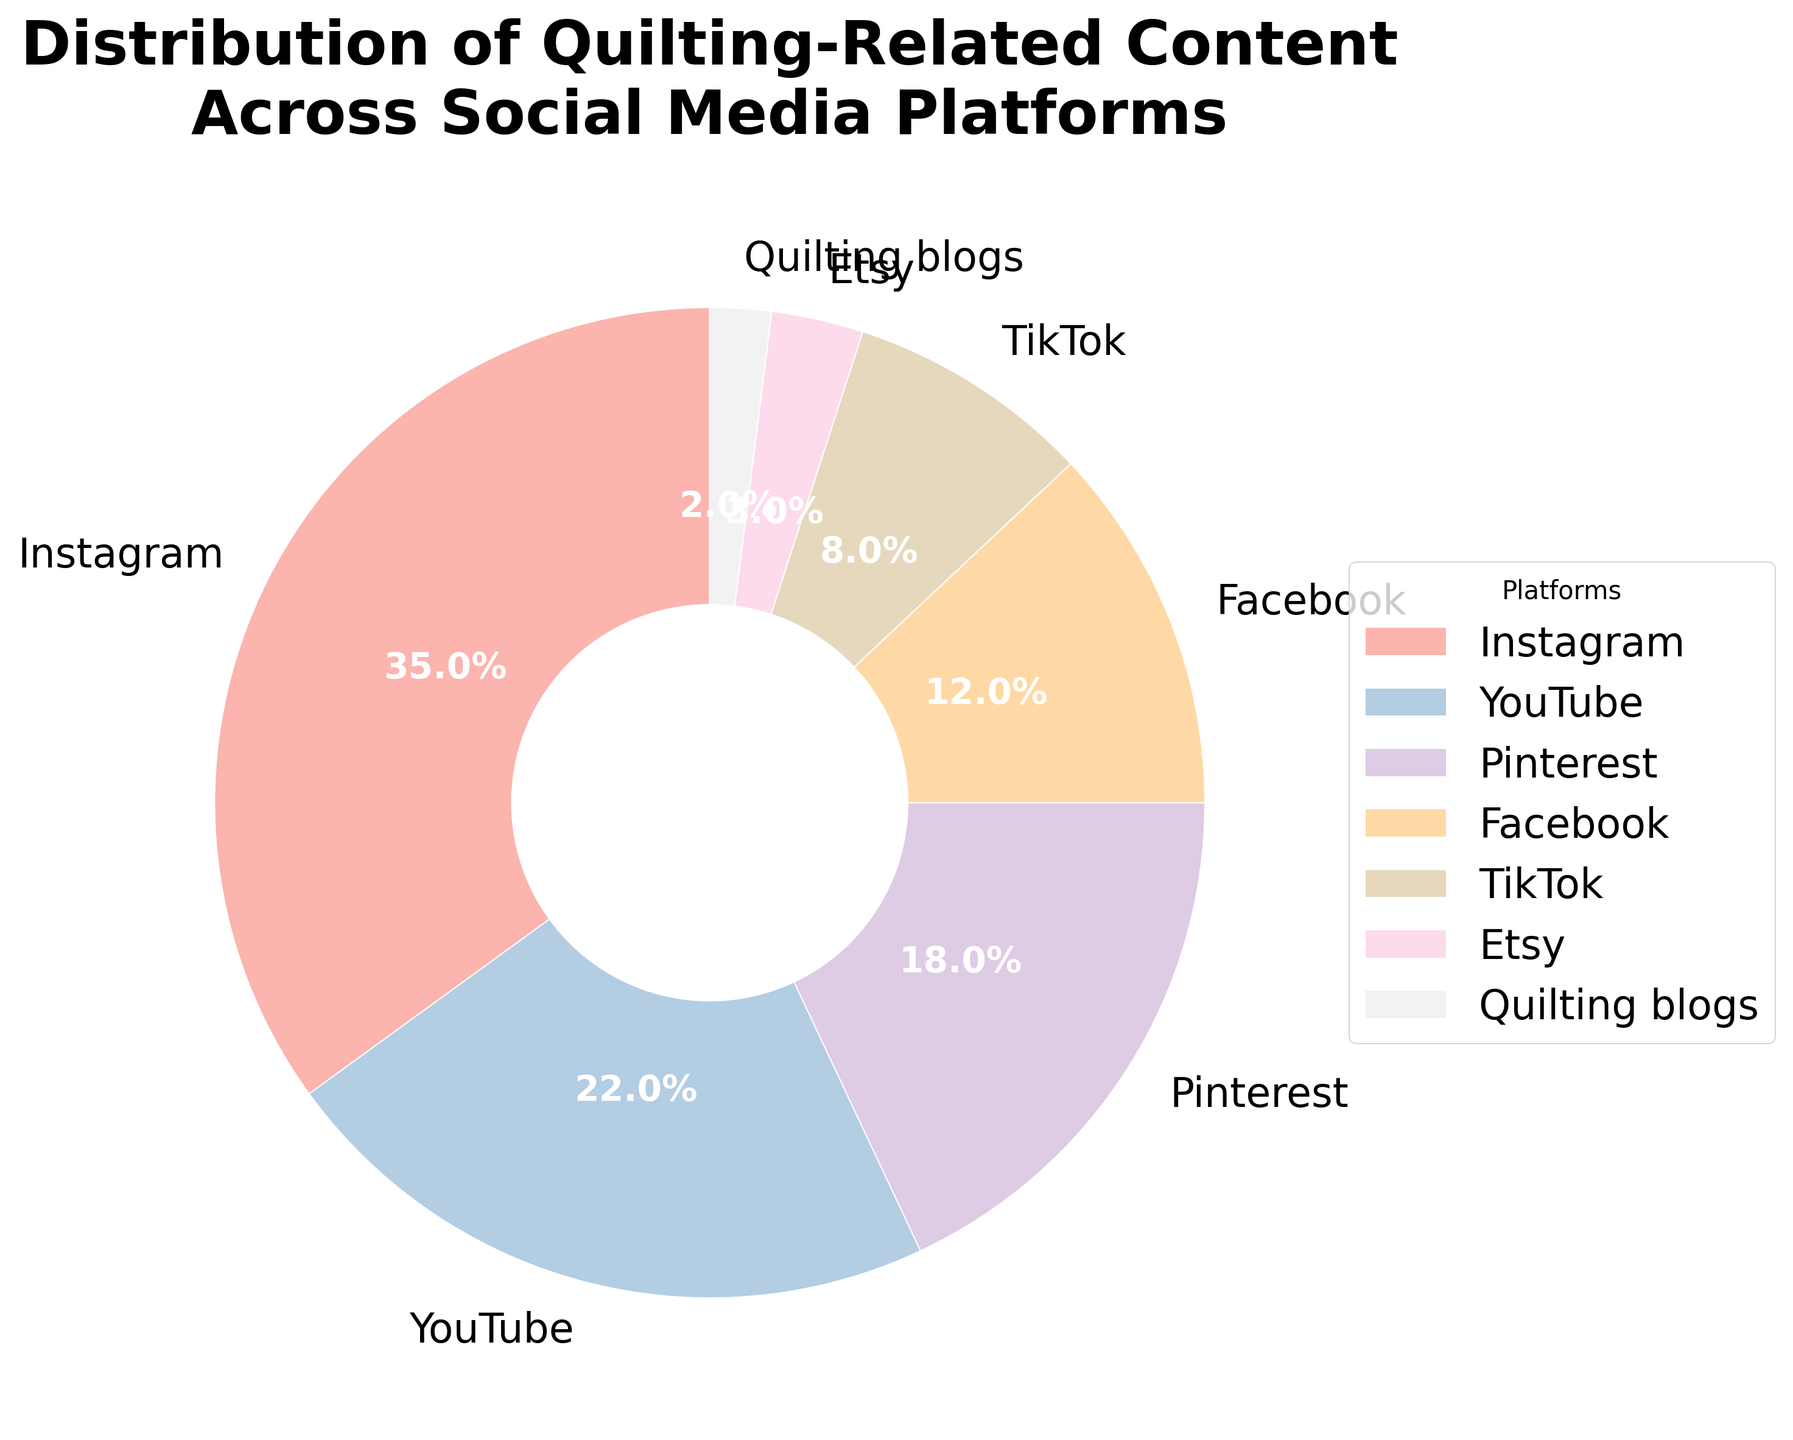Which platform holds the largest share of quilting-related content? The figure visually shows the slices of the pie chart, with Instagram having the largest section, representing 35%.
Answer: Instagram Which platform has the second largest share of quilting-related content? The next largest slice on the pie chart after Instagram is labeled YouTube, which has a percentage of 22%.
Answer: YouTube How much more percentage of quilting-related content does Instagram have compared to Facebook? Instagram has 35% while Facebook has 12%. Subtracting Facebook's share from Instagram's (35% - 12%) gives 23%.
Answer: 23% List the platforms that collectively make up less than 10% of the content. The slices labeled TikTok, Etsy, and Quilting blogs have percentages of 8%, 3%, and 2% respectively. Adding these up (8% + 3% + 2%) gives 13%, but only TikTok is below 10%.
Answer: TikTok, Etsy, Quilting blogs Which platform has the smallest share of quilting-related content? The smallest slice on the pie chart is labeled Quilting blogs, which shows a percentage of 2%.
Answer: Quilting blogs Among Pinterest and Facebook, which has a larger share of quilting-related content? Comparing the sizes of the slices and checking the percentages, Pinterest has 18%, which is larger than Facebook's 12%.
Answer: Pinterest What is the combined percentage of content on Instagram and TikTok? Adding the percentages for Instagram (35%) and TikTok (8%) gives 43%.
Answer: 43% If the content distribution represented 1000 pieces of content, how many pieces are from Facebook? Given Facebook's share is 12%, multiplying 1000 by 0.12 gives 120 pieces of content.
Answer: 120 Which platforms have a share of quilting-related content greater than 15%? By observing the pie chart, Instagram (35%) and YouTube (22%) both have percentages over 15%, while Pinterest (18%) also fits this criterion.
Answer: Instagram, YouTube, Pinterest What is the difference in percentage points between the total share of content on visual-based platforms (Instagram, Pinterest) and text-based platforms (Quilting blogs)? The pie chart shows Instagram and Pinterest at 35% and 18%, respectively. Summing these gives 53%. Quilting blogs are at 2%. The difference is 53% - 2% = 51%.
Answer: 51% 